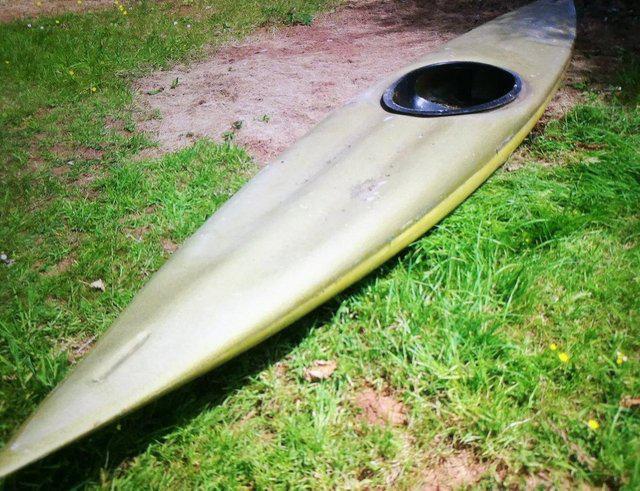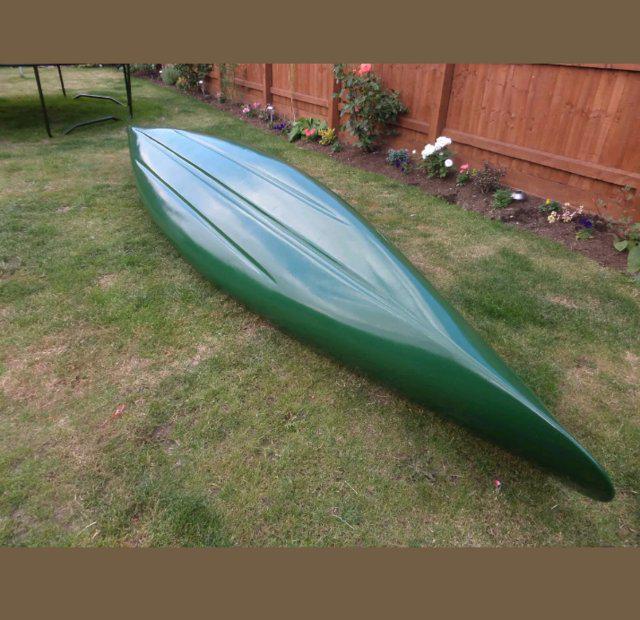The first image is the image on the left, the second image is the image on the right. Analyze the images presented: Is the assertion "there is an oar laying across the boat" valid? Answer yes or no. No. The first image is the image on the left, the second image is the image on the right. For the images shown, is this caption "The canoe is facing left in both images." true? Answer yes or no. No. 